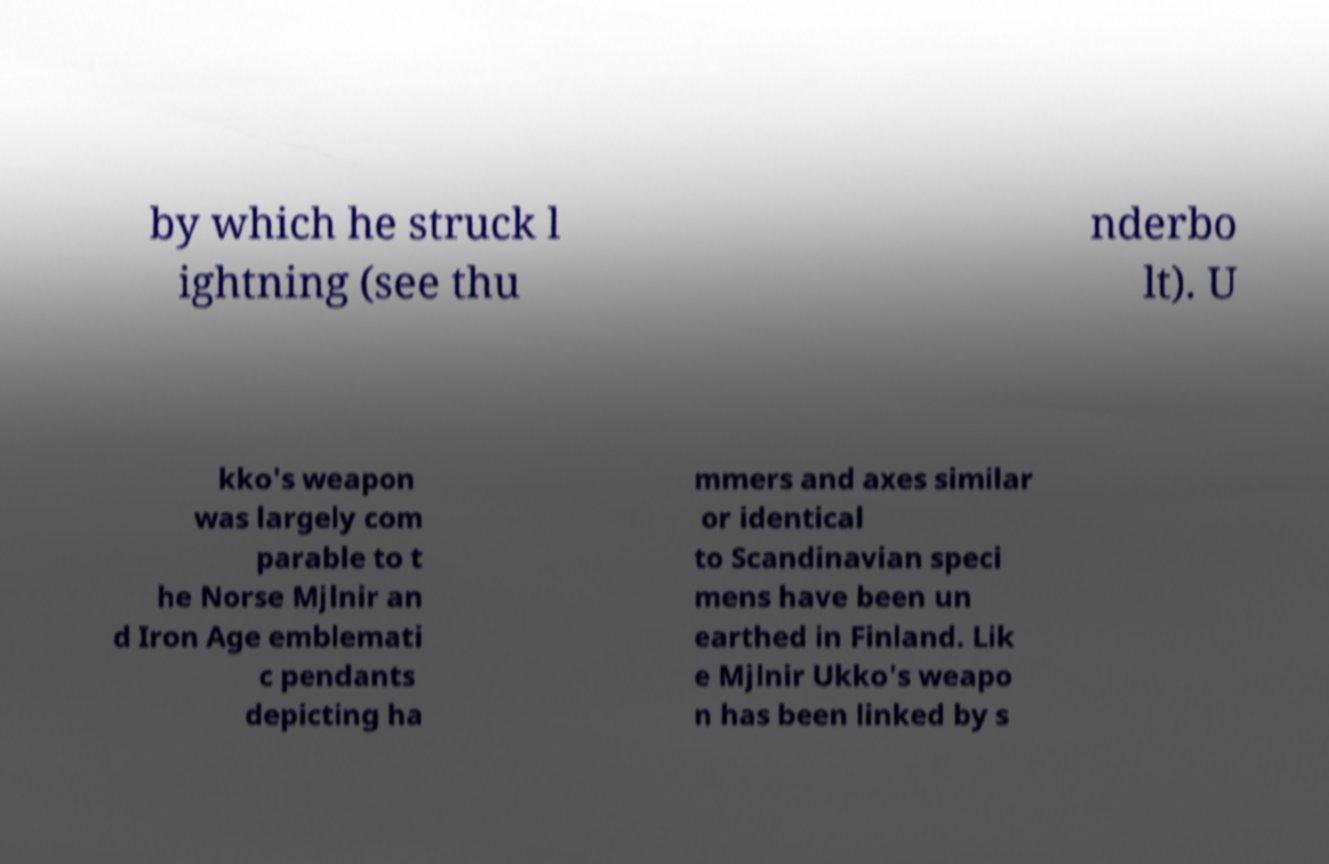For documentation purposes, I need the text within this image transcribed. Could you provide that? by which he struck l ightning (see thu nderbo lt). U kko's weapon was largely com parable to t he Norse Mjlnir an d Iron Age emblemati c pendants depicting ha mmers and axes similar or identical to Scandinavian speci mens have been un earthed in Finland. Lik e Mjlnir Ukko's weapo n has been linked by s 